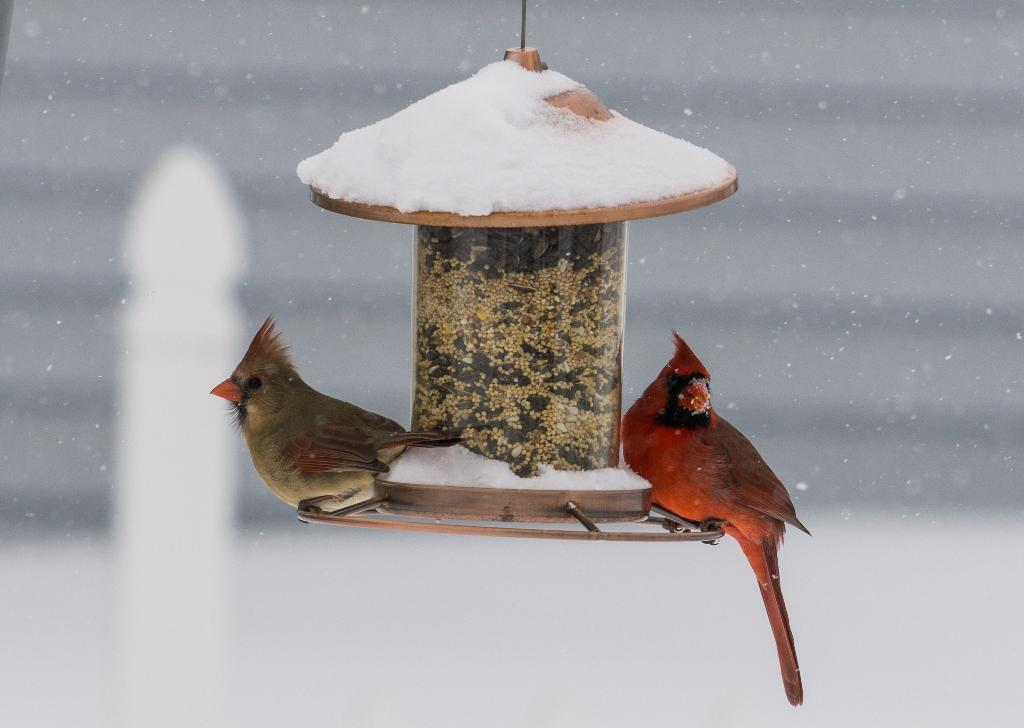What is hanging in the image? There is an object hanging in the image. What is covering the hanging object? Snow is covering the hanging object. What animals are sitting on the hanging object? Two birds are sitting on the hanging object. Can you describe the background of the image? The background of the image is blurry. What type of amusement can be seen in the image? There is no amusement present in the image; it features a hanging object with snow and birds. Can you tell me how many corks are visible in the image? There are no corks visible in the image. 